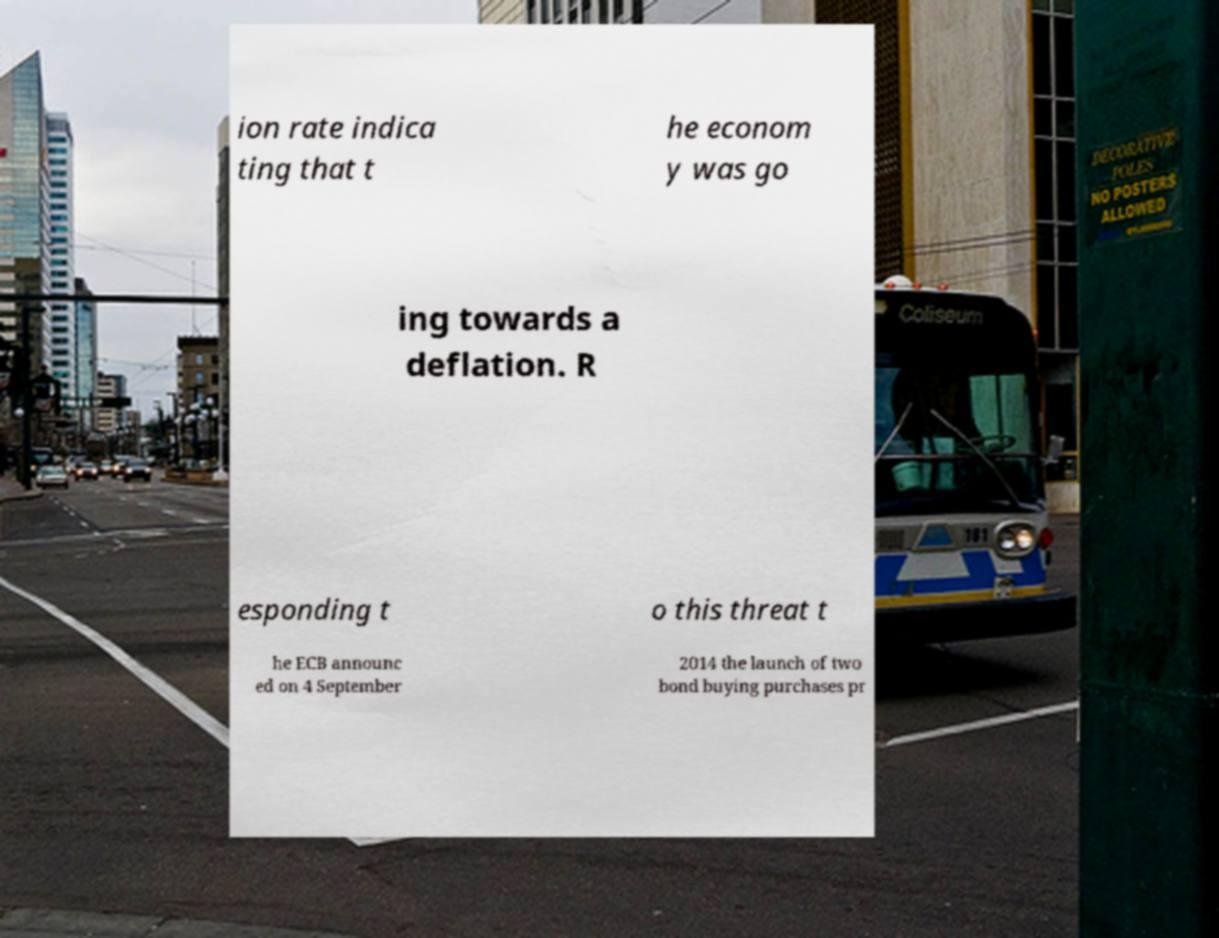What messages or text are displayed in this image? I need them in a readable, typed format. ion rate indica ting that t he econom y was go ing towards a deflation. R esponding t o this threat t he ECB announc ed on 4 September 2014 the launch of two bond buying purchases pr 